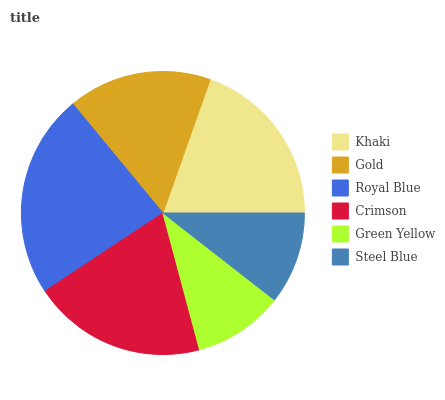Is Green Yellow the minimum?
Answer yes or no. Yes. Is Royal Blue the maximum?
Answer yes or no. Yes. Is Gold the minimum?
Answer yes or no. No. Is Gold the maximum?
Answer yes or no. No. Is Khaki greater than Gold?
Answer yes or no. Yes. Is Gold less than Khaki?
Answer yes or no. Yes. Is Gold greater than Khaki?
Answer yes or no. No. Is Khaki less than Gold?
Answer yes or no. No. Is Khaki the high median?
Answer yes or no. Yes. Is Gold the low median?
Answer yes or no. Yes. Is Steel Blue the high median?
Answer yes or no. No. Is Royal Blue the low median?
Answer yes or no. No. 